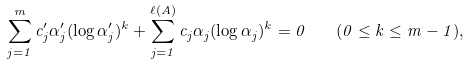<formula> <loc_0><loc_0><loc_500><loc_500>\sum _ { j = 1 } ^ { m } c ^ { \prime } _ { j } \alpha ^ { \prime } _ { j } ( \log \alpha ^ { \prime } _ { j } ) ^ { k } + \sum _ { j = 1 } ^ { \ell ( A ) } c _ { j } \alpha _ { j } ( \log \alpha _ { j } ) ^ { k } = 0 \quad ( 0 \leq k \leq m - 1 ) ,</formula> 